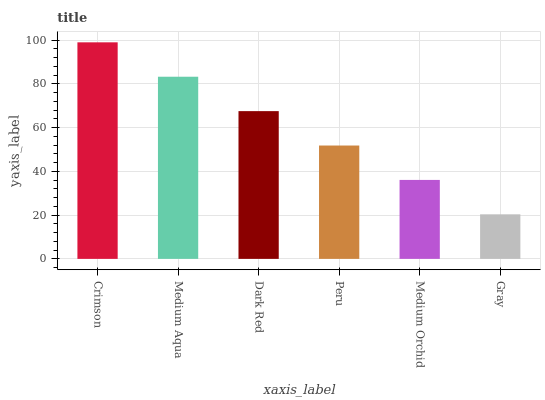Is Gray the minimum?
Answer yes or no. Yes. Is Crimson the maximum?
Answer yes or no. Yes. Is Medium Aqua the minimum?
Answer yes or no. No. Is Medium Aqua the maximum?
Answer yes or no. No. Is Crimson greater than Medium Aqua?
Answer yes or no. Yes. Is Medium Aqua less than Crimson?
Answer yes or no. Yes. Is Medium Aqua greater than Crimson?
Answer yes or no. No. Is Crimson less than Medium Aqua?
Answer yes or no. No. Is Dark Red the high median?
Answer yes or no. Yes. Is Peru the low median?
Answer yes or no. Yes. Is Medium Aqua the high median?
Answer yes or no. No. Is Gray the low median?
Answer yes or no. No. 